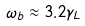Convert formula to latex. <formula><loc_0><loc_0><loc_500><loc_500>\omega _ { b } \approx 3 . 2 \gamma _ { L }</formula> 